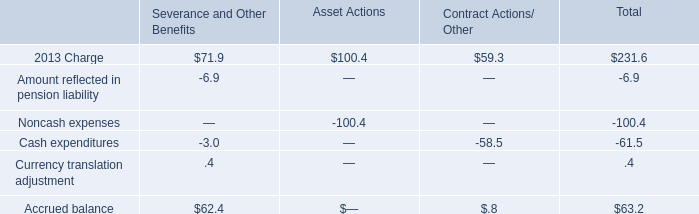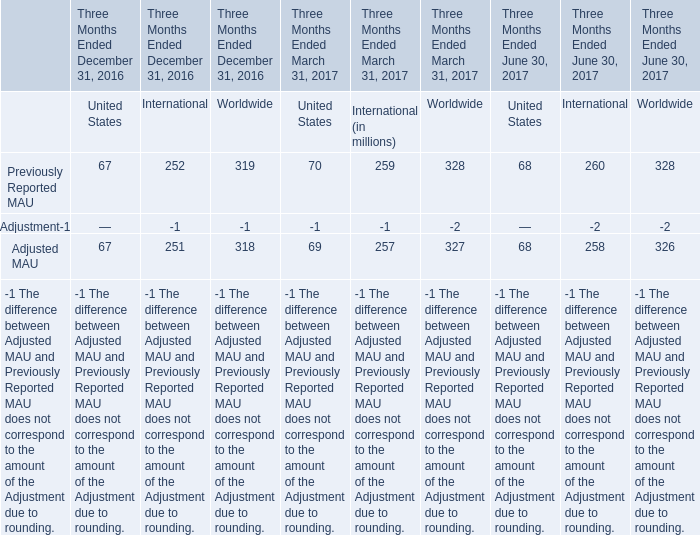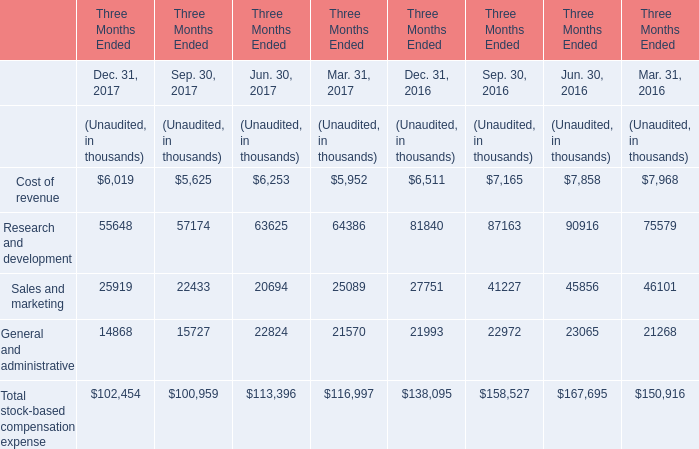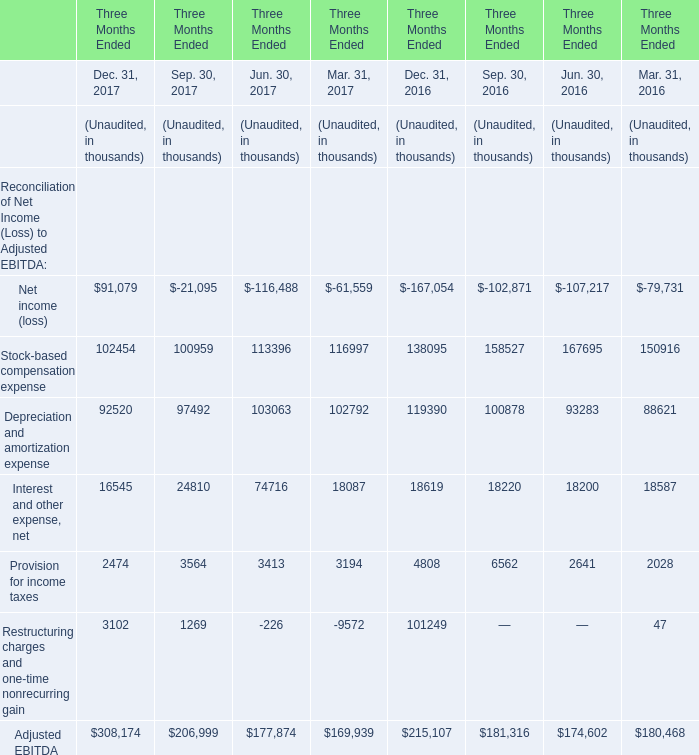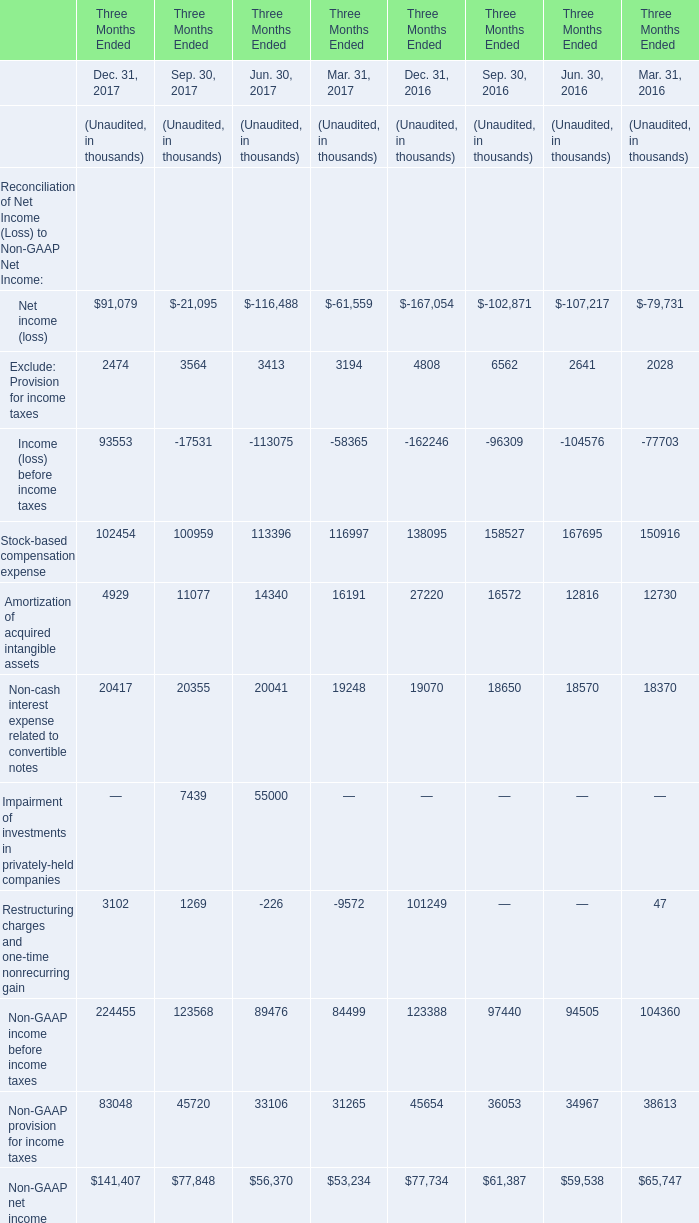As As the chart 2 shows, in 2017 ,the stock-based compensation expense of Sales and marketing Unaudited in quarter what is the lowest? 
Answer: 2. 